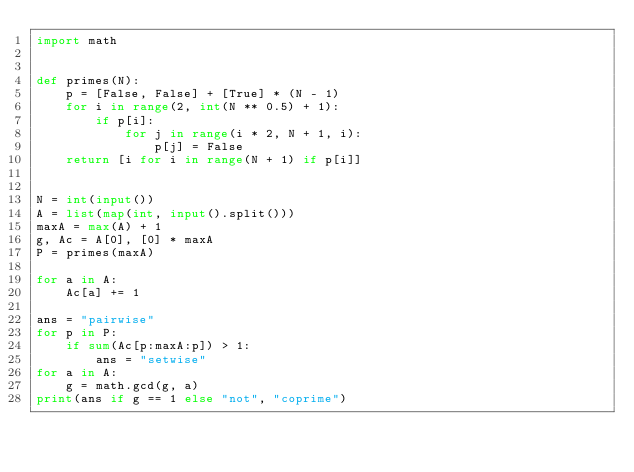Convert code to text. <code><loc_0><loc_0><loc_500><loc_500><_Python_>import math


def primes(N):
    p = [False, False] + [True] * (N - 1)
    for i in range(2, int(N ** 0.5) + 1):
        if p[i]:
            for j in range(i * 2, N + 1, i):
                p[j] = False
    return [i for i in range(N + 1) if p[i]]


N = int(input())
A = list(map(int, input().split()))
maxA = max(A) + 1
g, Ac = A[0], [0] * maxA
P = primes(maxA)

for a in A:
    Ac[a] += 1

ans = "pairwise"
for p in P:
    if sum(Ac[p:maxA:p]) > 1:
        ans = "setwise"
for a in A:
    g = math.gcd(g, a)
print(ans if g == 1 else "not", "coprime")
</code> 